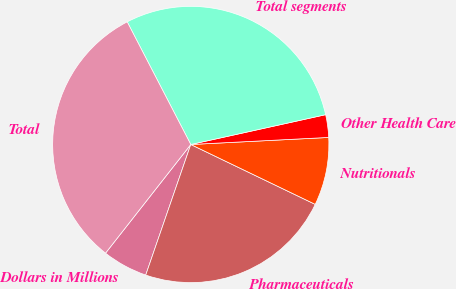<chart> <loc_0><loc_0><loc_500><loc_500><pie_chart><fcel>Dollars in Millions<fcel>Pharmaceuticals<fcel>Nutritionals<fcel>Other Health Care<fcel>Total segments<fcel>Total<nl><fcel>5.3%<fcel>23.15%<fcel>7.95%<fcel>2.65%<fcel>29.15%<fcel>31.8%<nl></chart> 